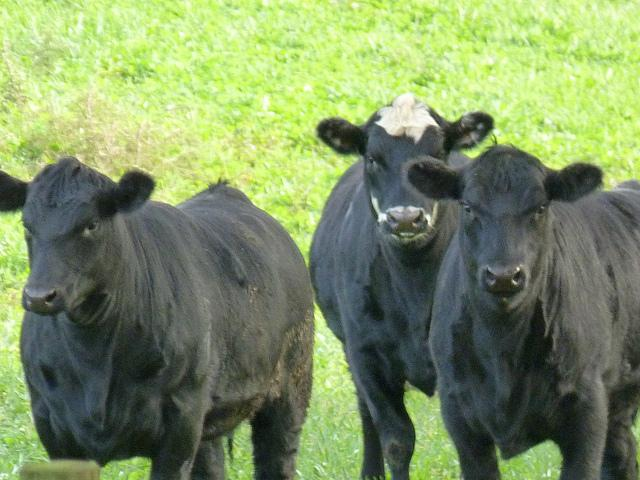How many black cows are standing up in the middle of the pasture? three 